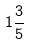Convert formula to latex. <formula><loc_0><loc_0><loc_500><loc_500>1 \frac { 3 } { 5 }</formula> 